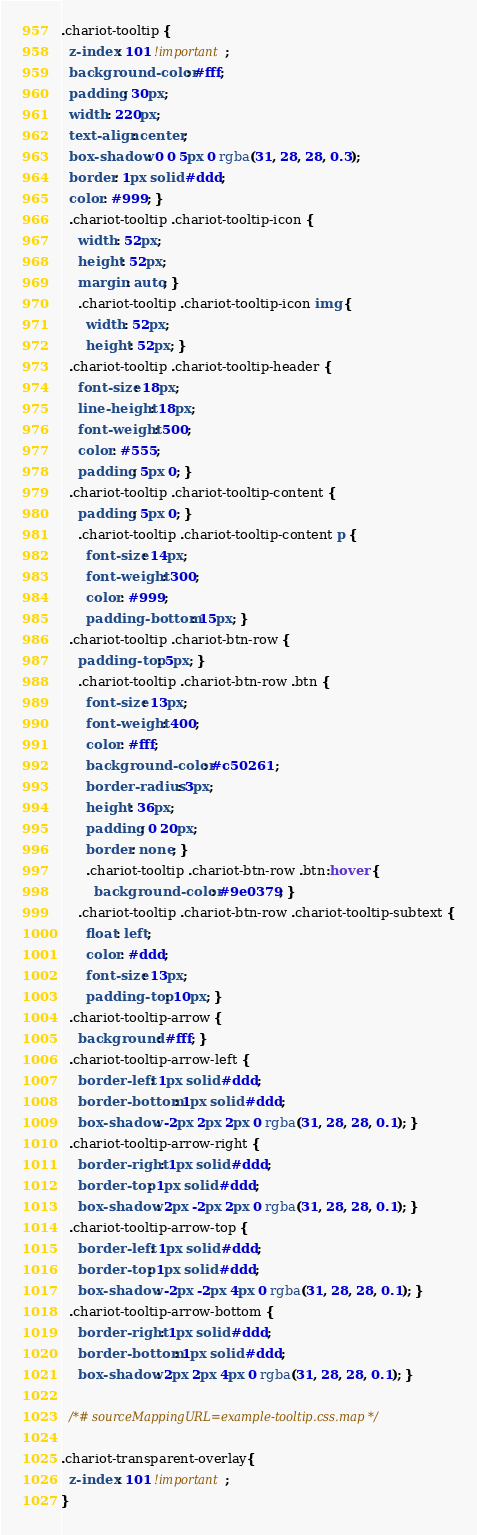<code> <loc_0><loc_0><loc_500><loc_500><_CSS_>.chariot-tooltip {
  z-index: 101 !important;
  background-color: #fff;
  padding: 30px;
  width: 220px;
  text-align: center;
  box-shadow: 0 0 5px 0 rgba(31, 28, 28, 0.3);
  border: 1px solid #ddd;
  color: #999; }
  .chariot-tooltip .chariot-tooltip-icon {
    width: 52px;
    height: 52px;
    margin: auto; }
    .chariot-tooltip .chariot-tooltip-icon img {
      width: 52px;
      height: 52px; }
  .chariot-tooltip .chariot-tooltip-header {
    font-size: 18px;
    line-height: 18px;
    font-weight: 500;
    color: #555;
    padding: 5px 0; }
  .chariot-tooltip .chariot-tooltip-content {
    padding: 5px 0; }
    .chariot-tooltip .chariot-tooltip-content p {
      font-size: 14px;
      font-weight: 300;
      color: #999;
      padding-bottom: 15px; }
  .chariot-tooltip .chariot-btn-row {
    padding-top: 5px; }
    .chariot-tooltip .chariot-btn-row .btn {
      font-size: 13px;
      font-weight: 400;
      color: #fff;
      background-color: #c50261 ;
      border-radius: 3px;
      height: 36px;
      padding: 0 20px;
      border: none; }
      .chariot-tooltip .chariot-btn-row .btn:hover {
        background-color: #9e0379; }
    .chariot-tooltip .chariot-btn-row .chariot-tooltip-subtext {
      float: left;
      color: #ddd;
      font-size: 13px;
      padding-top: 10px; }
  .chariot-tooltip-arrow {
    background: #fff; }
  .chariot-tooltip-arrow-left {
    border-left: 1px solid #ddd;
    border-bottom: 1px solid #ddd;
    box-shadow: -2px 2px 2px 0 rgba(31, 28, 28, 0.1); }
  .chariot-tooltip-arrow-right {
    border-right: 1px solid #ddd;
    border-top: 1px solid #ddd;
    box-shadow: 2px -2px 2px 0 rgba(31, 28, 28, 0.1); }
  .chariot-tooltip-arrow-top {
    border-left: 1px solid #ddd;
    border-top: 1px solid #ddd;
    box-shadow: -2px -2px 4px 0 rgba(31, 28, 28, 0.1); }
  .chariot-tooltip-arrow-bottom {
    border-right: 1px solid #ddd;
    border-bottom: 1px solid #ddd;
    box-shadow: 2px 2px 4px 0 rgba(31, 28, 28, 0.1); }
  
  /*# sourceMappingURL=example-tooltip.css.map */
  
.chariot-transparent-overlay{
  z-index: 101 !important;
}</code> 